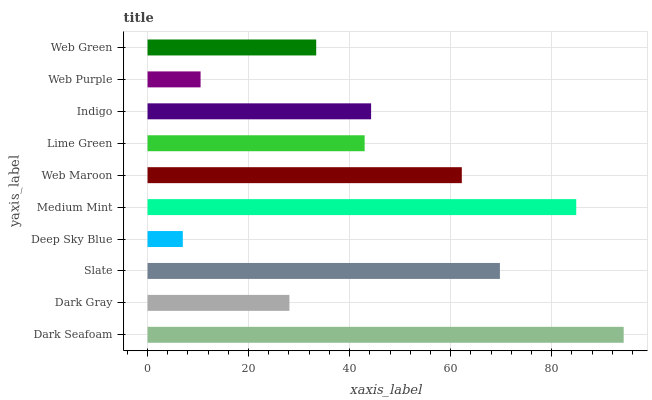Is Deep Sky Blue the minimum?
Answer yes or no. Yes. Is Dark Seafoam the maximum?
Answer yes or no. Yes. Is Dark Gray the minimum?
Answer yes or no. No. Is Dark Gray the maximum?
Answer yes or no. No. Is Dark Seafoam greater than Dark Gray?
Answer yes or no. Yes. Is Dark Gray less than Dark Seafoam?
Answer yes or no. Yes. Is Dark Gray greater than Dark Seafoam?
Answer yes or no. No. Is Dark Seafoam less than Dark Gray?
Answer yes or no. No. Is Indigo the high median?
Answer yes or no. Yes. Is Lime Green the low median?
Answer yes or no. Yes. Is Medium Mint the high median?
Answer yes or no. No. Is Dark Gray the low median?
Answer yes or no. No. 